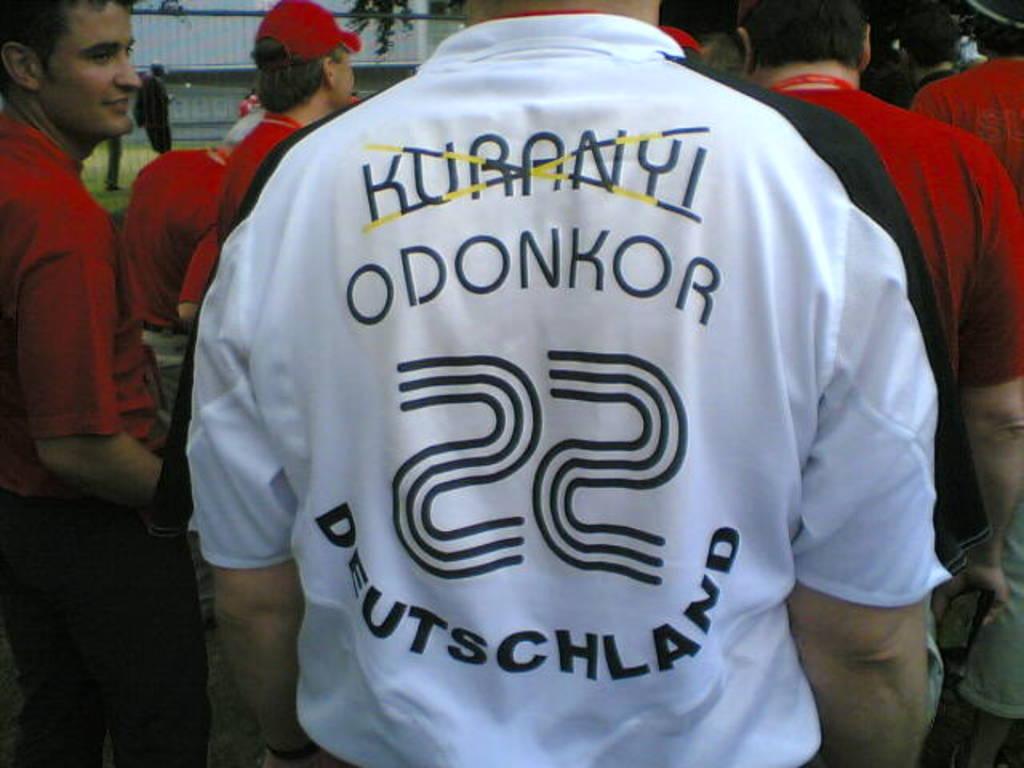What is the name that is not crossed out?
Give a very brief answer. Odonkor. 